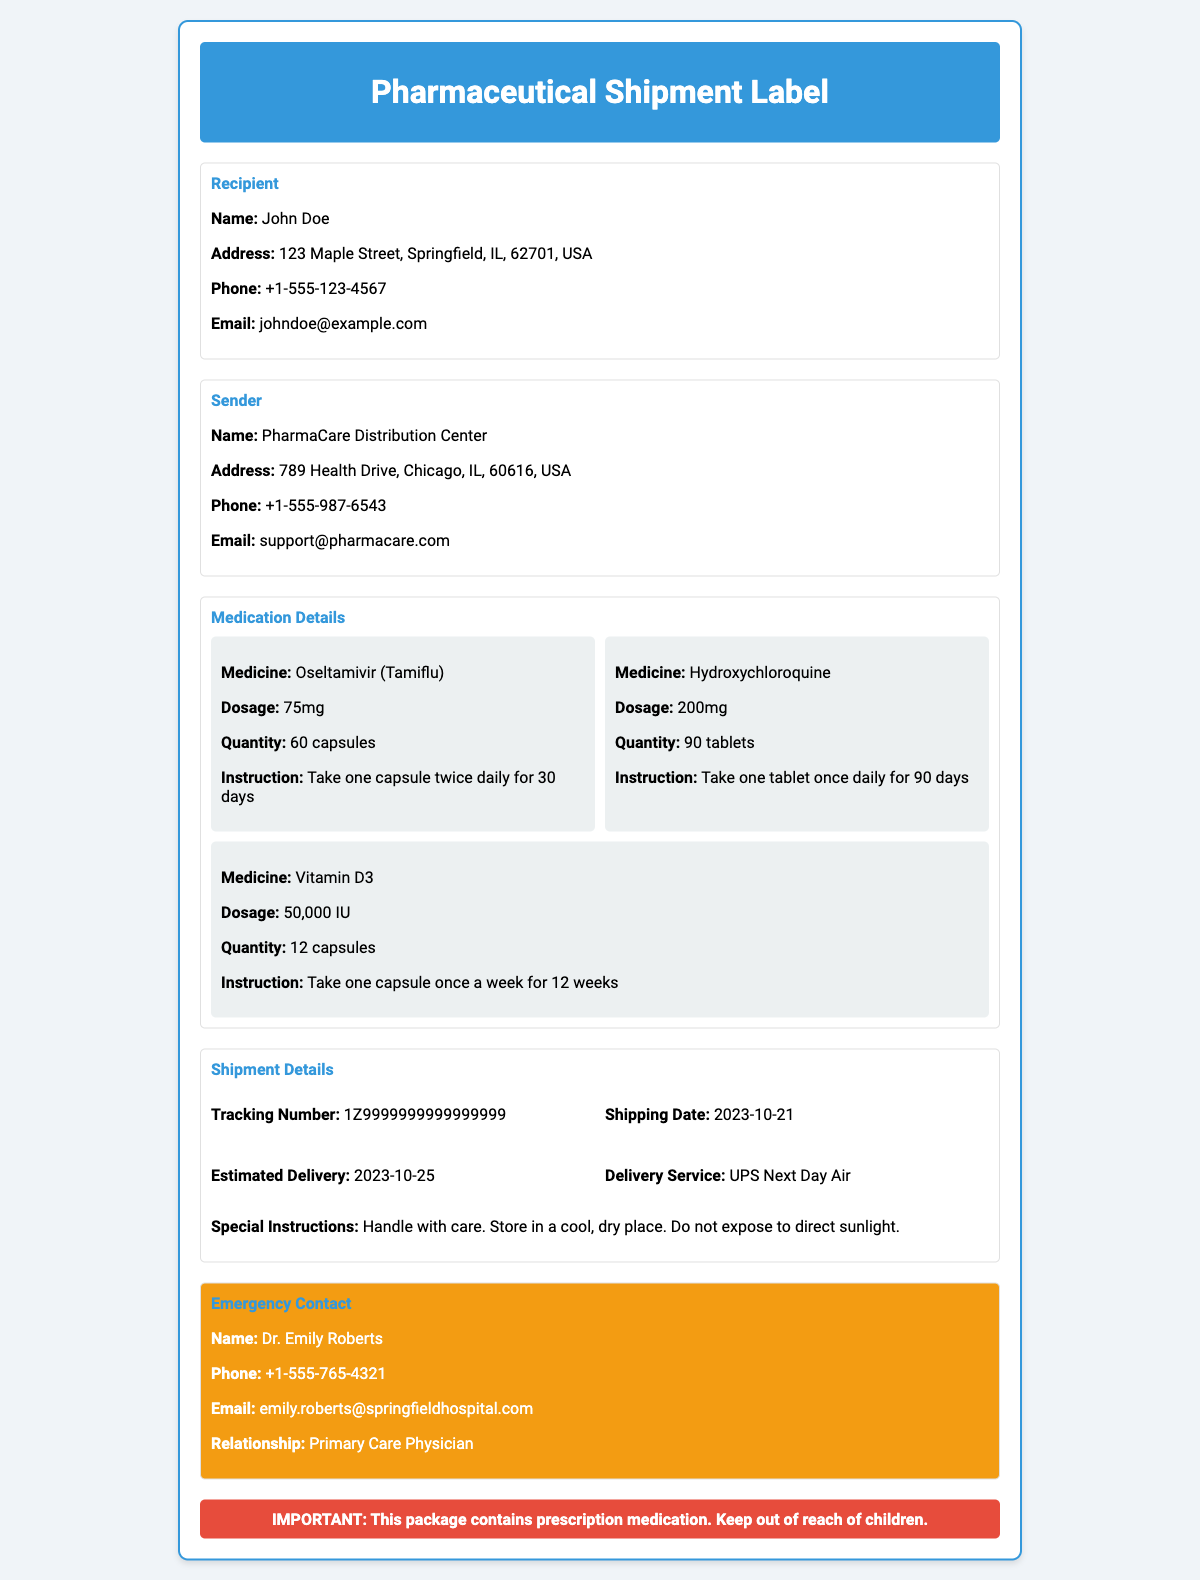what is the recipient's name? The recipient's name is specified in the "Recipient" section of the document.
Answer: John Doe what is the shipping date? The shipping date is mentioned under "Shipment Details".
Answer: 2023-10-21 how many capsules of Oseltamivir are included? The quantity of Oseltamivir is given in the "Medication Details" section.
Answer: 60 capsules who is the emergency contact? The name of the emergency contact is found in the "Emergency Contact" section.
Answer: Dr. Emily Roberts what is the dosage of Hydroxychloroquine? The dosage for Hydroxychloroquine is specified in the "Medication Details" section.
Answer: 200mg what is the estimated delivery date? The estimated delivery date is indicated in the "Shipment Details".
Answer: 2023-10-25 what is the relationship of the emergency contact? The relationship of the emergency contact is mentioned in the "Emergency Contact" section.
Answer: Primary Care Physician what is the special instruction for the shipment? The special instruction is noted under "Shipment Details".
Answer: Handle with care. Store in a cool, dry place. Do not expose to direct sunlight 